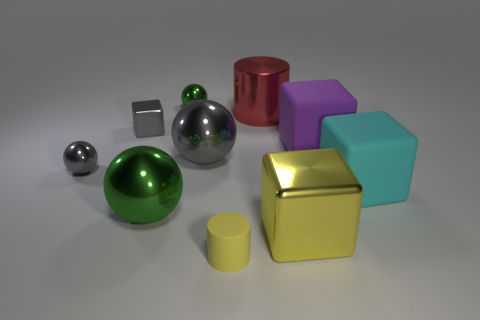There is a shiny cube on the right side of the rubber cylinder; is it the same color as the small rubber cylinder?
Provide a short and direct response. Yes. What number of other things are there of the same size as the red shiny cylinder?
Keep it short and to the point. 5. There is a yellow metallic cube; how many gray balls are behind it?
Your answer should be compact. 2. Are there an equal number of large green metallic balls that are on the right side of the big green metal ball and gray metallic balls that are right of the large cyan cube?
Your answer should be compact. Yes. The gray shiny object that is the same shape as the large cyan object is what size?
Provide a short and direct response. Small. The large green metallic object that is in front of the tiny metallic cube has what shape?
Give a very brief answer. Sphere. Are the yellow thing behind the rubber cylinder and the green sphere in front of the red cylinder made of the same material?
Provide a short and direct response. Yes. There is a yellow metal object; what shape is it?
Offer a terse response. Cube. Is the number of red shiny objects behind the large cyan matte thing the same as the number of shiny cylinders?
Your answer should be compact. Yes. What size is the metallic thing that is the same color as the small rubber cylinder?
Your response must be concise. Large. 